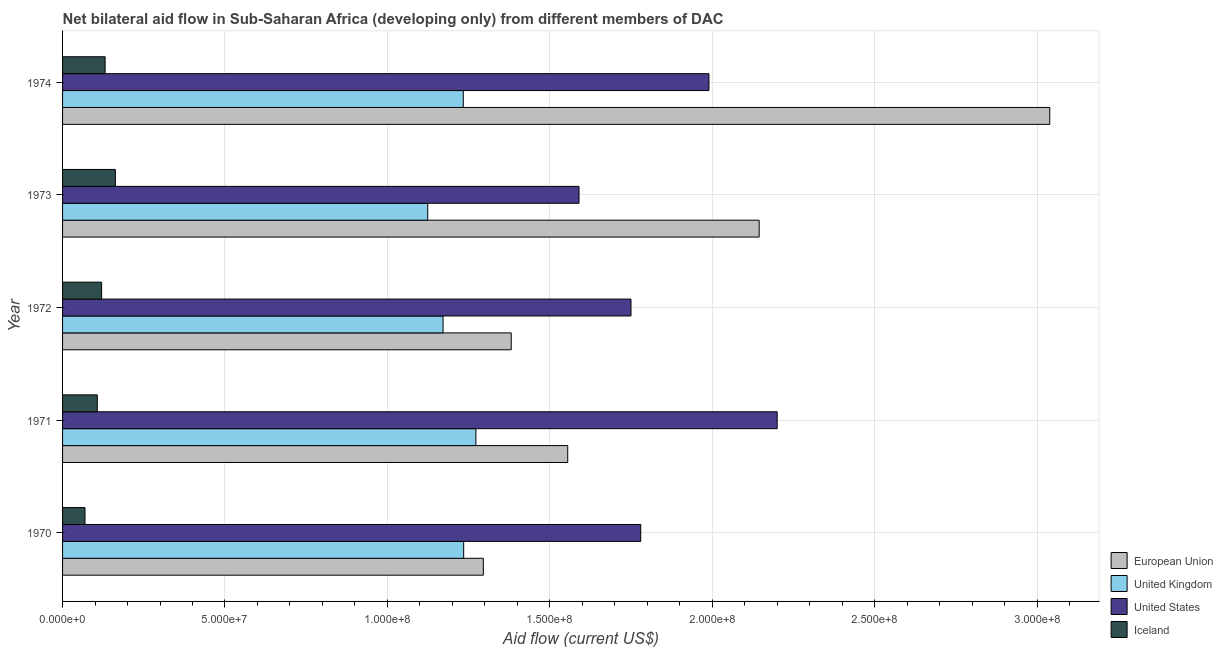How many groups of bars are there?
Ensure brevity in your answer.  5. Are the number of bars on each tick of the Y-axis equal?
Your answer should be compact. Yes. What is the label of the 4th group of bars from the top?
Keep it short and to the point. 1971. In how many cases, is the number of bars for a given year not equal to the number of legend labels?
Provide a succinct answer. 0. What is the amount of aid given by eu in 1972?
Offer a terse response. 1.38e+08. Across all years, what is the maximum amount of aid given by eu?
Your answer should be very brief. 3.04e+08. Across all years, what is the minimum amount of aid given by uk?
Offer a terse response. 1.12e+08. In which year was the amount of aid given by eu maximum?
Your answer should be compact. 1974. In which year was the amount of aid given by eu minimum?
Ensure brevity in your answer.  1970. What is the total amount of aid given by eu in the graph?
Provide a succinct answer. 9.42e+08. What is the difference between the amount of aid given by eu in 1971 and that in 1973?
Ensure brevity in your answer.  -5.89e+07. What is the difference between the amount of aid given by eu in 1972 and the amount of aid given by uk in 1973?
Make the answer very short. 2.57e+07. What is the average amount of aid given by us per year?
Your response must be concise. 1.86e+08. In the year 1973, what is the difference between the amount of aid given by uk and amount of aid given by eu?
Your response must be concise. -1.02e+08. What is the ratio of the amount of aid given by iceland in 1970 to that in 1973?
Keep it short and to the point. 0.42. Is the amount of aid given by iceland in 1972 less than that in 1973?
Provide a short and direct response. Yes. What is the difference between the highest and the second highest amount of aid given by us?
Provide a succinct answer. 2.10e+07. What is the difference between the highest and the lowest amount of aid given by eu?
Offer a very short reply. 1.74e+08. In how many years, is the amount of aid given by uk greater than the average amount of aid given by uk taken over all years?
Your answer should be very brief. 3. Is it the case that in every year, the sum of the amount of aid given by eu and amount of aid given by uk is greater than the amount of aid given by us?
Offer a terse response. Yes. Are all the bars in the graph horizontal?
Make the answer very short. Yes. What is the difference between two consecutive major ticks on the X-axis?
Keep it short and to the point. 5.00e+07. Are the values on the major ticks of X-axis written in scientific E-notation?
Ensure brevity in your answer.  Yes. Does the graph contain any zero values?
Your response must be concise. No. How are the legend labels stacked?
Your answer should be very brief. Vertical. What is the title of the graph?
Your answer should be very brief. Net bilateral aid flow in Sub-Saharan Africa (developing only) from different members of DAC. What is the label or title of the Y-axis?
Your answer should be very brief. Year. What is the Aid flow (current US$) of European Union in 1970?
Ensure brevity in your answer.  1.30e+08. What is the Aid flow (current US$) of United Kingdom in 1970?
Provide a short and direct response. 1.23e+08. What is the Aid flow (current US$) in United States in 1970?
Offer a very short reply. 1.78e+08. What is the Aid flow (current US$) in Iceland in 1970?
Your answer should be very brief. 6.90e+06. What is the Aid flow (current US$) of European Union in 1971?
Keep it short and to the point. 1.56e+08. What is the Aid flow (current US$) in United Kingdom in 1971?
Make the answer very short. 1.27e+08. What is the Aid flow (current US$) in United States in 1971?
Give a very brief answer. 2.20e+08. What is the Aid flow (current US$) of Iceland in 1971?
Make the answer very short. 1.07e+07. What is the Aid flow (current US$) in European Union in 1972?
Give a very brief answer. 1.38e+08. What is the Aid flow (current US$) of United Kingdom in 1972?
Provide a short and direct response. 1.17e+08. What is the Aid flow (current US$) in United States in 1972?
Your answer should be compact. 1.75e+08. What is the Aid flow (current US$) in Iceland in 1972?
Offer a terse response. 1.20e+07. What is the Aid flow (current US$) of European Union in 1973?
Your response must be concise. 2.14e+08. What is the Aid flow (current US$) in United Kingdom in 1973?
Give a very brief answer. 1.12e+08. What is the Aid flow (current US$) of United States in 1973?
Make the answer very short. 1.59e+08. What is the Aid flow (current US$) in Iceland in 1973?
Ensure brevity in your answer.  1.62e+07. What is the Aid flow (current US$) in European Union in 1974?
Make the answer very short. 3.04e+08. What is the Aid flow (current US$) of United Kingdom in 1974?
Your answer should be compact. 1.23e+08. What is the Aid flow (current US$) of United States in 1974?
Ensure brevity in your answer.  1.99e+08. What is the Aid flow (current US$) in Iceland in 1974?
Provide a succinct answer. 1.31e+07. Across all years, what is the maximum Aid flow (current US$) in European Union?
Provide a succinct answer. 3.04e+08. Across all years, what is the maximum Aid flow (current US$) in United Kingdom?
Give a very brief answer. 1.27e+08. Across all years, what is the maximum Aid flow (current US$) in United States?
Offer a terse response. 2.20e+08. Across all years, what is the maximum Aid flow (current US$) in Iceland?
Your answer should be very brief. 1.62e+07. Across all years, what is the minimum Aid flow (current US$) of European Union?
Your response must be concise. 1.30e+08. Across all years, what is the minimum Aid flow (current US$) of United Kingdom?
Your response must be concise. 1.12e+08. Across all years, what is the minimum Aid flow (current US$) of United States?
Provide a succinct answer. 1.59e+08. Across all years, what is the minimum Aid flow (current US$) in Iceland?
Provide a succinct answer. 6.90e+06. What is the total Aid flow (current US$) of European Union in the graph?
Ensure brevity in your answer.  9.42e+08. What is the total Aid flow (current US$) in United Kingdom in the graph?
Ensure brevity in your answer.  6.04e+08. What is the total Aid flow (current US$) of United States in the graph?
Your response must be concise. 9.31e+08. What is the total Aid flow (current US$) of Iceland in the graph?
Provide a succinct answer. 5.90e+07. What is the difference between the Aid flow (current US$) in European Union in 1970 and that in 1971?
Your response must be concise. -2.60e+07. What is the difference between the Aid flow (current US$) of United Kingdom in 1970 and that in 1971?
Make the answer very short. -3.76e+06. What is the difference between the Aid flow (current US$) in United States in 1970 and that in 1971?
Ensure brevity in your answer.  -4.20e+07. What is the difference between the Aid flow (current US$) in Iceland in 1970 and that in 1971?
Keep it short and to the point. -3.79e+06. What is the difference between the Aid flow (current US$) of European Union in 1970 and that in 1972?
Ensure brevity in your answer.  -8.59e+06. What is the difference between the Aid flow (current US$) of United Kingdom in 1970 and that in 1972?
Make the answer very short. 6.35e+06. What is the difference between the Aid flow (current US$) of United States in 1970 and that in 1972?
Give a very brief answer. 3.00e+06. What is the difference between the Aid flow (current US$) in Iceland in 1970 and that in 1972?
Make the answer very short. -5.12e+06. What is the difference between the Aid flow (current US$) in European Union in 1970 and that in 1973?
Your response must be concise. -8.49e+07. What is the difference between the Aid flow (current US$) in United Kingdom in 1970 and that in 1973?
Your response must be concise. 1.11e+07. What is the difference between the Aid flow (current US$) in United States in 1970 and that in 1973?
Your response must be concise. 1.90e+07. What is the difference between the Aid flow (current US$) in Iceland in 1970 and that in 1973?
Make the answer very short. -9.35e+06. What is the difference between the Aid flow (current US$) in European Union in 1970 and that in 1974?
Ensure brevity in your answer.  -1.74e+08. What is the difference between the Aid flow (current US$) in United Kingdom in 1970 and that in 1974?
Your answer should be compact. 1.20e+05. What is the difference between the Aid flow (current US$) of United States in 1970 and that in 1974?
Keep it short and to the point. -2.10e+07. What is the difference between the Aid flow (current US$) of Iceland in 1970 and that in 1974?
Your response must be concise. -6.20e+06. What is the difference between the Aid flow (current US$) in European Union in 1971 and that in 1972?
Ensure brevity in your answer.  1.74e+07. What is the difference between the Aid flow (current US$) in United Kingdom in 1971 and that in 1972?
Provide a succinct answer. 1.01e+07. What is the difference between the Aid flow (current US$) in United States in 1971 and that in 1972?
Offer a terse response. 4.50e+07. What is the difference between the Aid flow (current US$) in Iceland in 1971 and that in 1972?
Make the answer very short. -1.33e+06. What is the difference between the Aid flow (current US$) in European Union in 1971 and that in 1973?
Give a very brief answer. -5.89e+07. What is the difference between the Aid flow (current US$) of United Kingdom in 1971 and that in 1973?
Provide a short and direct response. 1.48e+07. What is the difference between the Aid flow (current US$) in United States in 1971 and that in 1973?
Make the answer very short. 6.10e+07. What is the difference between the Aid flow (current US$) in Iceland in 1971 and that in 1973?
Offer a very short reply. -5.56e+06. What is the difference between the Aid flow (current US$) in European Union in 1971 and that in 1974?
Offer a terse response. -1.48e+08. What is the difference between the Aid flow (current US$) in United Kingdom in 1971 and that in 1974?
Your response must be concise. 3.88e+06. What is the difference between the Aid flow (current US$) in United States in 1971 and that in 1974?
Ensure brevity in your answer.  2.10e+07. What is the difference between the Aid flow (current US$) in Iceland in 1971 and that in 1974?
Offer a very short reply. -2.41e+06. What is the difference between the Aid flow (current US$) of European Union in 1972 and that in 1973?
Give a very brief answer. -7.63e+07. What is the difference between the Aid flow (current US$) of United Kingdom in 1972 and that in 1973?
Your answer should be very brief. 4.72e+06. What is the difference between the Aid flow (current US$) of United States in 1972 and that in 1973?
Give a very brief answer. 1.60e+07. What is the difference between the Aid flow (current US$) in Iceland in 1972 and that in 1973?
Your answer should be very brief. -4.23e+06. What is the difference between the Aid flow (current US$) of European Union in 1972 and that in 1974?
Your response must be concise. -1.66e+08. What is the difference between the Aid flow (current US$) in United Kingdom in 1972 and that in 1974?
Your answer should be very brief. -6.23e+06. What is the difference between the Aid flow (current US$) of United States in 1972 and that in 1974?
Make the answer very short. -2.40e+07. What is the difference between the Aid flow (current US$) in Iceland in 1972 and that in 1974?
Offer a very short reply. -1.08e+06. What is the difference between the Aid flow (current US$) in European Union in 1973 and that in 1974?
Give a very brief answer. -8.95e+07. What is the difference between the Aid flow (current US$) in United Kingdom in 1973 and that in 1974?
Provide a short and direct response. -1.10e+07. What is the difference between the Aid flow (current US$) of United States in 1973 and that in 1974?
Provide a short and direct response. -4.00e+07. What is the difference between the Aid flow (current US$) of Iceland in 1973 and that in 1974?
Keep it short and to the point. 3.15e+06. What is the difference between the Aid flow (current US$) of European Union in 1970 and the Aid flow (current US$) of United Kingdom in 1971?
Provide a short and direct response. 2.29e+06. What is the difference between the Aid flow (current US$) of European Union in 1970 and the Aid flow (current US$) of United States in 1971?
Your answer should be compact. -9.05e+07. What is the difference between the Aid flow (current US$) of European Union in 1970 and the Aid flow (current US$) of Iceland in 1971?
Your response must be concise. 1.19e+08. What is the difference between the Aid flow (current US$) in United Kingdom in 1970 and the Aid flow (current US$) in United States in 1971?
Make the answer very short. -9.65e+07. What is the difference between the Aid flow (current US$) in United Kingdom in 1970 and the Aid flow (current US$) in Iceland in 1971?
Your answer should be very brief. 1.13e+08. What is the difference between the Aid flow (current US$) of United States in 1970 and the Aid flow (current US$) of Iceland in 1971?
Your response must be concise. 1.67e+08. What is the difference between the Aid flow (current US$) in European Union in 1970 and the Aid flow (current US$) in United Kingdom in 1972?
Offer a terse response. 1.24e+07. What is the difference between the Aid flow (current US$) in European Union in 1970 and the Aid flow (current US$) in United States in 1972?
Your answer should be very brief. -4.55e+07. What is the difference between the Aid flow (current US$) in European Union in 1970 and the Aid flow (current US$) in Iceland in 1972?
Offer a terse response. 1.18e+08. What is the difference between the Aid flow (current US$) of United Kingdom in 1970 and the Aid flow (current US$) of United States in 1972?
Keep it short and to the point. -5.15e+07. What is the difference between the Aid flow (current US$) of United Kingdom in 1970 and the Aid flow (current US$) of Iceland in 1972?
Offer a very short reply. 1.11e+08. What is the difference between the Aid flow (current US$) of United States in 1970 and the Aid flow (current US$) of Iceland in 1972?
Your answer should be compact. 1.66e+08. What is the difference between the Aid flow (current US$) of European Union in 1970 and the Aid flow (current US$) of United Kingdom in 1973?
Your answer should be compact. 1.71e+07. What is the difference between the Aid flow (current US$) of European Union in 1970 and the Aid flow (current US$) of United States in 1973?
Offer a terse response. -2.95e+07. What is the difference between the Aid flow (current US$) of European Union in 1970 and the Aid flow (current US$) of Iceland in 1973?
Offer a terse response. 1.13e+08. What is the difference between the Aid flow (current US$) of United Kingdom in 1970 and the Aid flow (current US$) of United States in 1973?
Your answer should be very brief. -3.55e+07. What is the difference between the Aid flow (current US$) in United Kingdom in 1970 and the Aid flow (current US$) in Iceland in 1973?
Give a very brief answer. 1.07e+08. What is the difference between the Aid flow (current US$) of United States in 1970 and the Aid flow (current US$) of Iceland in 1973?
Your answer should be compact. 1.62e+08. What is the difference between the Aid flow (current US$) in European Union in 1970 and the Aid flow (current US$) in United Kingdom in 1974?
Offer a terse response. 6.17e+06. What is the difference between the Aid flow (current US$) of European Union in 1970 and the Aid flow (current US$) of United States in 1974?
Offer a very short reply. -6.95e+07. What is the difference between the Aid flow (current US$) in European Union in 1970 and the Aid flow (current US$) in Iceland in 1974?
Ensure brevity in your answer.  1.16e+08. What is the difference between the Aid flow (current US$) of United Kingdom in 1970 and the Aid flow (current US$) of United States in 1974?
Make the answer very short. -7.55e+07. What is the difference between the Aid flow (current US$) of United Kingdom in 1970 and the Aid flow (current US$) of Iceland in 1974?
Keep it short and to the point. 1.10e+08. What is the difference between the Aid flow (current US$) of United States in 1970 and the Aid flow (current US$) of Iceland in 1974?
Your answer should be very brief. 1.65e+08. What is the difference between the Aid flow (current US$) in European Union in 1971 and the Aid flow (current US$) in United Kingdom in 1972?
Offer a very short reply. 3.84e+07. What is the difference between the Aid flow (current US$) of European Union in 1971 and the Aid flow (current US$) of United States in 1972?
Keep it short and to the point. -1.95e+07. What is the difference between the Aid flow (current US$) of European Union in 1971 and the Aid flow (current US$) of Iceland in 1972?
Your response must be concise. 1.44e+08. What is the difference between the Aid flow (current US$) of United Kingdom in 1971 and the Aid flow (current US$) of United States in 1972?
Keep it short and to the point. -4.78e+07. What is the difference between the Aid flow (current US$) in United Kingdom in 1971 and the Aid flow (current US$) in Iceland in 1972?
Offer a very short reply. 1.15e+08. What is the difference between the Aid flow (current US$) in United States in 1971 and the Aid flow (current US$) in Iceland in 1972?
Your answer should be compact. 2.08e+08. What is the difference between the Aid flow (current US$) of European Union in 1971 and the Aid flow (current US$) of United Kingdom in 1973?
Provide a succinct answer. 4.31e+07. What is the difference between the Aid flow (current US$) of European Union in 1971 and the Aid flow (current US$) of United States in 1973?
Your response must be concise. -3.48e+06. What is the difference between the Aid flow (current US$) in European Union in 1971 and the Aid flow (current US$) in Iceland in 1973?
Make the answer very short. 1.39e+08. What is the difference between the Aid flow (current US$) in United Kingdom in 1971 and the Aid flow (current US$) in United States in 1973?
Give a very brief answer. -3.18e+07. What is the difference between the Aid flow (current US$) in United Kingdom in 1971 and the Aid flow (current US$) in Iceland in 1973?
Give a very brief answer. 1.11e+08. What is the difference between the Aid flow (current US$) of United States in 1971 and the Aid flow (current US$) of Iceland in 1973?
Offer a very short reply. 2.04e+08. What is the difference between the Aid flow (current US$) of European Union in 1971 and the Aid flow (current US$) of United Kingdom in 1974?
Ensure brevity in your answer.  3.22e+07. What is the difference between the Aid flow (current US$) in European Union in 1971 and the Aid flow (current US$) in United States in 1974?
Your answer should be very brief. -4.35e+07. What is the difference between the Aid flow (current US$) of European Union in 1971 and the Aid flow (current US$) of Iceland in 1974?
Offer a very short reply. 1.42e+08. What is the difference between the Aid flow (current US$) in United Kingdom in 1971 and the Aid flow (current US$) in United States in 1974?
Offer a terse response. -7.18e+07. What is the difference between the Aid flow (current US$) in United Kingdom in 1971 and the Aid flow (current US$) in Iceland in 1974?
Provide a succinct answer. 1.14e+08. What is the difference between the Aid flow (current US$) of United States in 1971 and the Aid flow (current US$) of Iceland in 1974?
Your answer should be compact. 2.07e+08. What is the difference between the Aid flow (current US$) of European Union in 1972 and the Aid flow (current US$) of United Kingdom in 1973?
Your answer should be very brief. 2.57e+07. What is the difference between the Aid flow (current US$) in European Union in 1972 and the Aid flow (current US$) in United States in 1973?
Provide a succinct answer. -2.09e+07. What is the difference between the Aid flow (current US$) of European Union in 1972 and the Aid flow (current US$) of Iceland in 1973?
Ensure brevity in your answer.  1.22e+08. What is the difference between the Aid flow (current US$) of United Kingdom in 1972 and the Aid flow (current US$) of United States in 1973?
Ensure brevity in your answer.  -4.19e+07. What is the difference between the Aid flow (current US$) in United Kingdom in 1972 and the Aid flow (current US$) in Iceland in 1973?
Give a very brief answer. 1.01e+08. What is the difference between the Aid flow (current US$) of United States in 1972 and the Aid flow (current US$) of Iceland in 1973?
Keep it short and to the point. 1.59e+08. What is the difference between the Aid flow (current US$) of European Union in 1972 and the Aid flow (current US$) of United Kingdom in 1974?
Your answer should be very brief. 1.48e+07. What is the difference between the Aid flow (current US$) in European Union in 1972 and the Aid flow (current US$) in United States in 1974?
Give a very brief answer. -6.09e+07. What is the difference between the Aid flow (current US$) of European Union in 1972 and the Aid flow (current US$) of Iceland in 1974?
Your response must be concise. 1.25e+08. What is the difference between the Aid flow (current US$) of United Kingdom in 1972 and the Aid flow (current US$) of United States in 1974?
Provide a succinct answer. -8.19e+07. What is the difference between the Aid flow (current US$) of United Kingdom in 1972 and the Aid flow (current US$) of Iceland in 1974?
Your response must be concise. 1.04e+08. What is the difference between the Aid flow (current US$) in United States in 1972 and the Aid flow (current US$) in Iceland in 1974?
Offer a very short reply. 1.62e+08. What is the difference between the Aid flow (current US$) of European Union in 1973 and the Aid flow (current US$) of United Kingdom in 1974?
Give a very brief answer. 9.11e+07. What is the difference between the Aid flow (current US$) of European Union in 1973 and the Aid flow (current US$) of United States in 1974?
Your answer should be compact. 1.55e+07. What is the difference between the Aid flow (current US$) in European Union in 1973 and the Aid flow (current US$) in Iceland in 1974?
Your answer should be compact. 2.01e+08. What is the difference between the Aid flow (current US$) in United Kingdom in 1973 and the Aid flow (current US$) in United States in 1974?
Your response must be concise. -8.66e+07. What is the difference between the Aid flow (current US$) in United Kingdom in 1973 and the Aid flow (current US$) in Iceland in 1974?
Offer a very short reply. 9.93e+07. What is the difference between the Aid flow (current US$) of United States in 1973 and the Aid flow (current US$) of Iceland in 1974?
Provide a short and direct response. 1.46e+08. What is the average Aid flow (current US$) of European Union per year?
Offer a terse response. 1.88e+08. What is the average Aid flow (current US$) in United Kingdom per year?
Offer a very short reply. 1.21e+08. What is the average Aid flow (current US$) in United States per year?
Give a very brief answer. 1.86e+08. What is the average Aid flow (current US$) in Iceland per year?
Keep it short and to the point. 1.18e+07. In the year 1970, what is the difference between the Aid flow (current US$) of European Union and Aid flow (current US$) of United Kingdom?
Your response must be concise. 6.05e+06. In the year 1970, what is the difference between the Aid flow (current US$) in European Union and Aid flow (current US$) in United States?
Your response must be concise. -4.85e+07. In the year 1970, what is the difference between the Aid flow (current US$) in European Union and Aid flow (current US$) in Iceland?
Offer a very short reply. 1.23e+08. In the year 1970, what is the difference between the Aid flow (current US$) in United Kingdom and Aid flow (current US$) in United States?
Make the answer very short. -5.45e+07. In the year 1970, what is the difference between the Aid flow (current US$) of United Kingdom and Aid flow (current US$) of Iceland?
Ensure brevity in your answer.  1.17e+08. In the year 1970, what is the difference between the Aid flow (current US$) in United States and Aid flow (current US$) in Iceland?
Keep it short and to the point. 1.71e+08. In the year 1971, what is the difference between the Aid flow (current US$) in European Union and Aid flow (current US$) in United Kingdom?
Your answer should be compact. 2.83e+07. In the year 1971, what is the difference between the Aid flow (current US$) in European Union and Aid flow (current US$) in United States?
Your answer should be very brief. -6.45e+07. In the year 1971, what is the difference between the Aid flow (current US$) in European Union and Aid flow (current US$) in Iceland?
Keep it short and to the point. 1.45e+08. In the year 1971, what is the difference between the Aid flow (current US$) in United Kingdom and Aid flow (current US$) in United States?
Offer a terse response. -9.28e+07. In the year 1971, what is the difference between the Aid flow (current US$) of United Kingdom and Aid flow (current US$) of Iceland?
Make the answer very short. 1.17e+08. In the year 1971, what is the difference between the Aid flow (current US$) of United States and Aid flow (current US$) of Iceland?
Offer a very short reply. 2.09e+08. In the year 1972, what is the difference between the Aid flow (current US$) of European Union and Aid flow (current US$) of United Kingdom?
Make the answer very short. 2.10e+07. In the year 1972, what is the difference between the Aid flow (current US$) in European Union and Aid flow (current US$) in United States?
Keep it short and to the point. -3.69e+07. In the year 1972, what is the difference between the Aid flow (current US$) in European Union and Aid flow (current US$) in Iceland?
Your answer should be compact. 1.26e+08. In the year 1972, what is the difference between the Aid flow (current US$) in United Kingdom and Aid flow (current US$) in United States?
Your answer should be very brief. -5.79e+07. In the year 1972, what is the difference between the Aid flow (current US$) in United Kingdom and Aid flow (current US$) in Iceland?
Make the answer very short. 1.05e+08. In the year 1972, what is the difference between the Aid flow (current US$) in United States and Aid flow (current US$) in Iceland?
Your answer should be compact. 1.63e+08. In the year 1973, what is the difference between the Aid flow (current US$) in European Union and Aid flow (current US$) in United Kingdom?
Your answer should be very brief. 1.02e+08. In the year 1973, what is the difference between the Aid flow (current US$) in European Union and Aid flow (current US$) in United States?
Your answer should be compact. 5.55e+07. In the year 1973, what is the difference between the Aid flow (current US$) of European Union and Aid flow (current US$) of Iceland?
Your answer should be compact. 1.98e+08. In the year 1973, what is the difference between the Aid flow (current US$) of United Kingdom and Aid flow (current US$) of United States?
Your response must be concise. -4.66e+07. In the year 1973, what is the difference between the Aid flow (current US$) of United Kingdom and Aid flow (current US$) of Iceland?
Give a very brief answer. 9.62e+07. In the year 1973, what is the difference between the Aid flow (current US$) of United States and Aid flow (current US$) of Iceland?
Make the answer very short. 1.43e+08. In the year 1974, what is the difference between the Aid flow (current US$) of European Union and Aid flow (current US$) of United Kingdom?
Offer a terse response. 1.81e+08. In the year 1974, what is the difference between the Aid flow (current US$) of European Union and Aid flow (current US$) of United States?
Offer a very short reply. 1.05e+08. In the year 1974, what is the difference between the Aid flow (current US$) of European Union and Aid flow (current US$) of Iceland?
Make the answer very short. 2.91e+08. In the year 1974, what is the difference between the Aid flow (current US$) of United Kingdom and Aid flow (current US$) of United States?
Provide a short and direct response. -7.56e+07. In the year 1974, what is the difference between the Aid flow (current US$) in United Kingdom and Aid flow (current US$) in Iceland?
Your response must be concise. 1.10e+08. In the year 1974, what is the difference between the Aid flow (current US$) in United States and Aid flow (current US$) in Iceland?
Make the answer very short. 1.86e+08. What is the ratio of the Aid flow (current US$) of European Union in 1970 to that in 1971?
Make the answer very short. 0.83. What is the ratio of the Aid flow (current US$) in United Kingdom in 1970 to that in 1971?
Ensure brevity in your answer.  0.97. What is the ratio of the Aid flow (current US$) of United States in 1970 to that in 1971?
Provide a succinct answer. 0.81. What is the ratio of the Aid flow (current US$) of Iceland in 1970 to that in 1971?
Ensure brevity in your answer.  0.65. What is the ratio of the Aid flow (current US$) in European Union in 1970 to that in 1972?
Your response must be concise. 0.94. What is the ratio of the Aid flow (current US$) of United Kingdom in 1970 to that in 1972?
Your answer should be compact. 1.05. What is the ratio of the Aid flow (current US$) of United States in 1970 to that in 1972?
Offer a very short reply. 1.02. What is the ratio of the Aid flow (current US$) of Iceland in 1970 to that in 1972?
Ensure brevity in your answer.  0.57. What is the ratio of the Aid flow (current US$) of European Union in 1970 to that in 1973?
Ensure brevity in your answer.  0.6. What is the ratio of the Aid flow (current US$) of United Kingdom in 1970 to that in 1973?
Provide a short and direct response. 1.1. What is the ratio of the Aid flow (current US$) in United States in 1970 to that in 1973?
Offer a very short reply. 1.12. What is the ratio of the Aid flow (current US$) in Iceland in 1970 to that in 1973?
Your answer should be very brief. 0.42. What is the ratio of the Aid flow (current US$) in European Union in 1970 to that in 1974?
Your response must be concise. 0.43. What is the ratio of the Aid flow (current US$) of United States in 1970 to that in 1974?
Offer a very short reply. 0.89. What is the ratio of the Aid flow (current US$) of Iceland in 1970 to that in 1974?
Your response must be concise. 0.53. What is the ratio of the Aid flow (current US$) in European Union in 1971 to that in 1972?
Ensure brevity in your answer.  1.13. What is the ratio of the Aid flow (current US$) of United Kingdom in 1971 to that in 1972?
Keep it short and to the point. 1.09. What is the ratio of the Aid flow (current US$) of United States in 1971 to that in 1972?
Your answer should be compact. 1.26. What is the ratio of the Aid flow (current US$) of Iceland in 1971 to that in 1972?
Make the answer very short. 0.89. What is the ratio of the Aid flow (current US$) in European Union in 1971 to that in 1973?
Keep it short and to the point. 0.73. What is the ratio of the Aid flow (current US$) of United Kingdom in 1971 to that in 1973?
Make the answer very short. 1.13. What is the ratio of the Aid flow (current US$) in United States in 1971 to that in 1973?
Your response must be concise. 1.38. What is the ratio of the Aid flow (current US$) in Iceland in 1971 to that in 1973?
Keep it short and to the point. 0.66. What is the ratio of the Aid flow (current US$) of European Union in 1971 to that in 1974?
Ensure brevity in your answer.  0.51. What is the ratio of the Aid flow (current US$) in United Kingdom in 1971 to that in 1974?
Give a very brief answer. 1.03. What is the ratio of the Aid flow (current US$) of United States in 1971 to that in 1974?
Offer a very short reply. 1.11. What is the ratio of the Aid flow (current US$) in Iceland in 1971 to that in 1974?
Give a very brief answer. 0.82. What is the ratio of the Aid flow (current US$) in European Union in 1972 to that in 1973?
Your response must be concise. 0.64. What is the ratio of the Aid flow (current US$) in United Kingdom in 1972 to that in 1973?
Offer a terse response. 1.04. What is the ratio of the Aid flow (current US$) in United States in 1972 to that in 1973?
Provide a short and direct response. 1.1. What is the ratio of the Aid flow (current US$) of Iceland in 1972 to that in 1973?
Offer a very short reply. 0.74. What is the ratio of the Aid flow (current US$) of European Union in 1972 to that in 1974?
Offer a very short reply. 0.45. What is the ratio of the Aid flow (current US$) in United Kingdom in 1972 to that in 1974?
Provide a short and direct response. 0.95. What is the ratio of the Aid flow (current US$) in United States in 1972 to that in 1974?
Provide a short and direct response. 0.88. What is the ratio of the Aid flow (current US$) of Iceland in 1972 to that in 1974?
Offer a very short reply. 0.92. What is the ratio of the Aid flow (current US$) of European Union in 1973 to that in 1974?
Your answer should be compact. 0.71. What is the ratio of the Aid flow (current US$) in United Kingdom in 1973 to that in 1974?
Keep it short and to the point. 0.91. What is the ratio of the Aid flow (current US$) in United States in 1973 to that in 1974?
Offer a terse response. 0.8. What is the ratio of the Aid flow (current US$) in Iceland in 1973 to that in 1974?
Your answer should be compact. 1.24. What is the difference between the highest and the second highest Aid flow (current US$) of European Union?
Offer a very short reply. 8.95e+07. What is the difference between the highest and the second highest Aid flow (current US$) of United Kingdom?
Make the answer very short. 3.76e+06. What is the difference between the highest and the second highest Aid flow (current US$) of United States?
Keep it short and to the point. 2.10e+07. What is the difference between the highest and the second highest Aid flow (current US$) of Iceland?
Make the answer very short. 3.15e+06. What is the difference between the highest and the lowest Aid flow (current US$) in European Union?
Make the answer very short. 1.74e+08. What is the difference between the highest and the lowest Aid flow (current US$) of United Kingdom?
Your response must be concise. 1.48e+07. What is the difference between the highest and the lowest Aid flow (current US$) of United States?
Your answer should be compact. 6.10e+07. What is the difference between the highest and the lowest Aid flow (current US$) of Iceland?
Your answer should be very brief. 9.35e+06. 